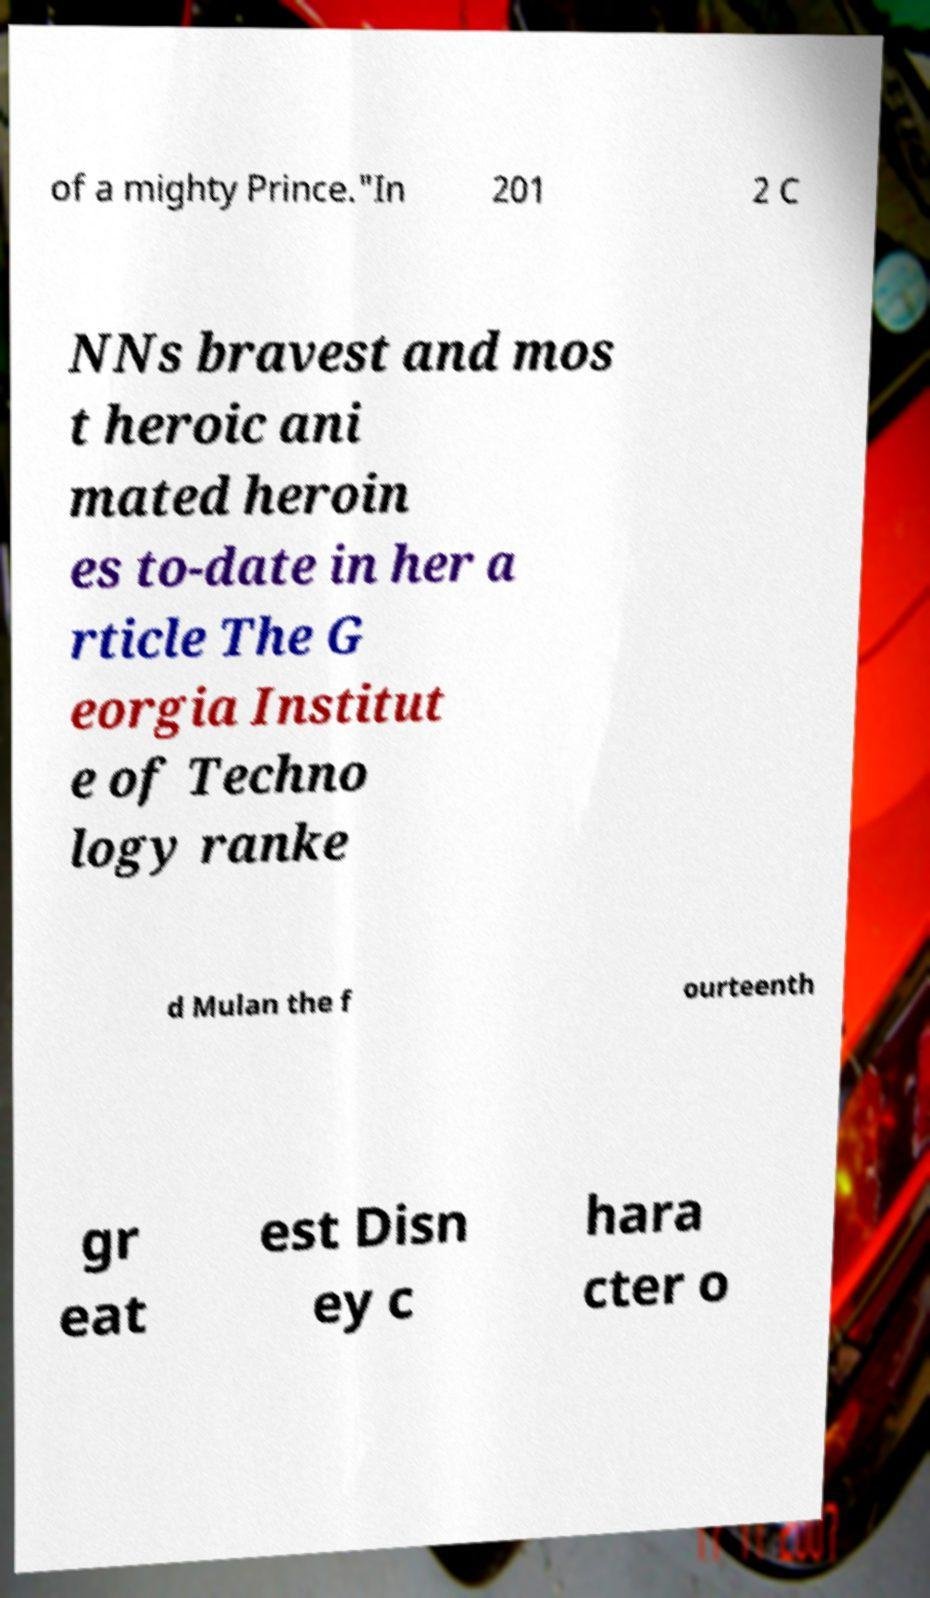Please identify and transcribe the text found in this image. of a mighty Prince."In 201 2 C NNs bravest and mos t heroic ani mated heroin es to-date in her a rticle The G eorgia Institut e of Techno logy ranke d Mulan the f ourteenth gr eat est Disn ey c hara cter o 